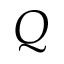Convert formula to latex. <formula><loc_0><loc_0><loc_500><loc_500>Q</formula> 